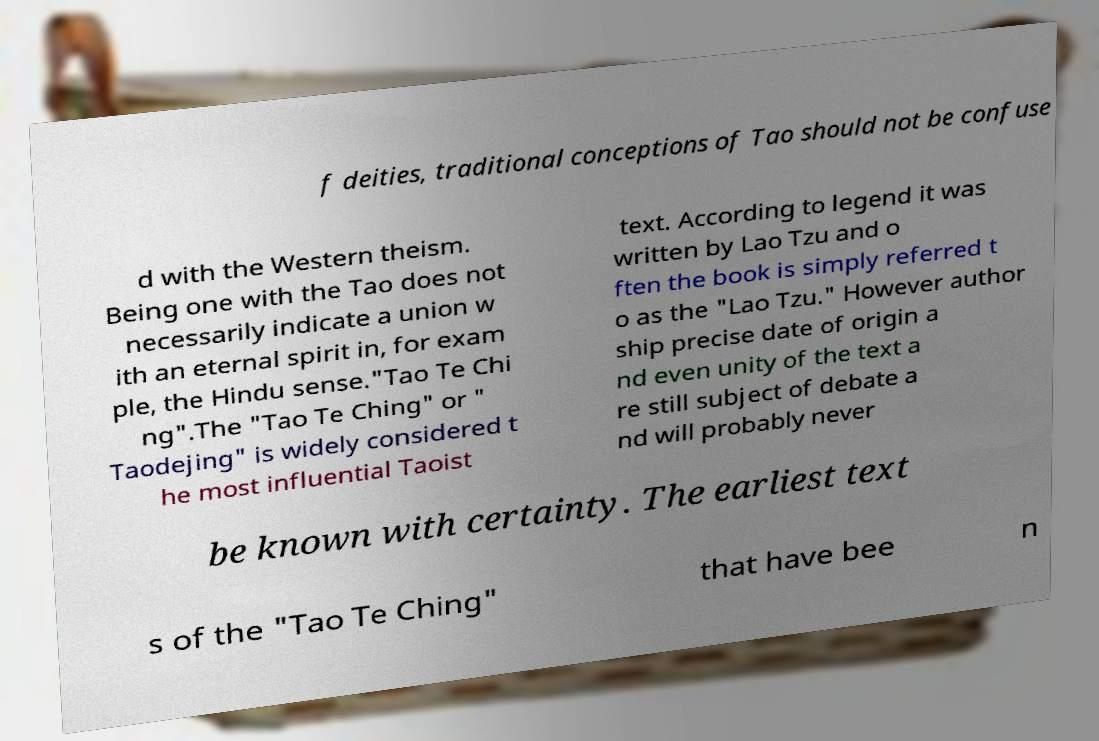There's text embedded in this image that I need extracted. Can you transcribe it verbatim? f deities, traditional conceptions of Tao should not be confuse d with the Western theism. Being one with the Tao does not necessarily indicate a union w ith an eternal spirit in, for exam ple, the Hindu sense."Tao Te Chi ng".The "Tao Te Ching" or " Taodejing" is widely considered t he most influential Taoist text. According to legend it was written by Lao Tzu and o ften the book is simply referred t o as the "Lao Tzu." However author ship precise date of origin a nd even unity of the text a re still subject of debate a nd will probably never be known with certainty. The earliest text s of the "Tao Te Ching" that have bee n 